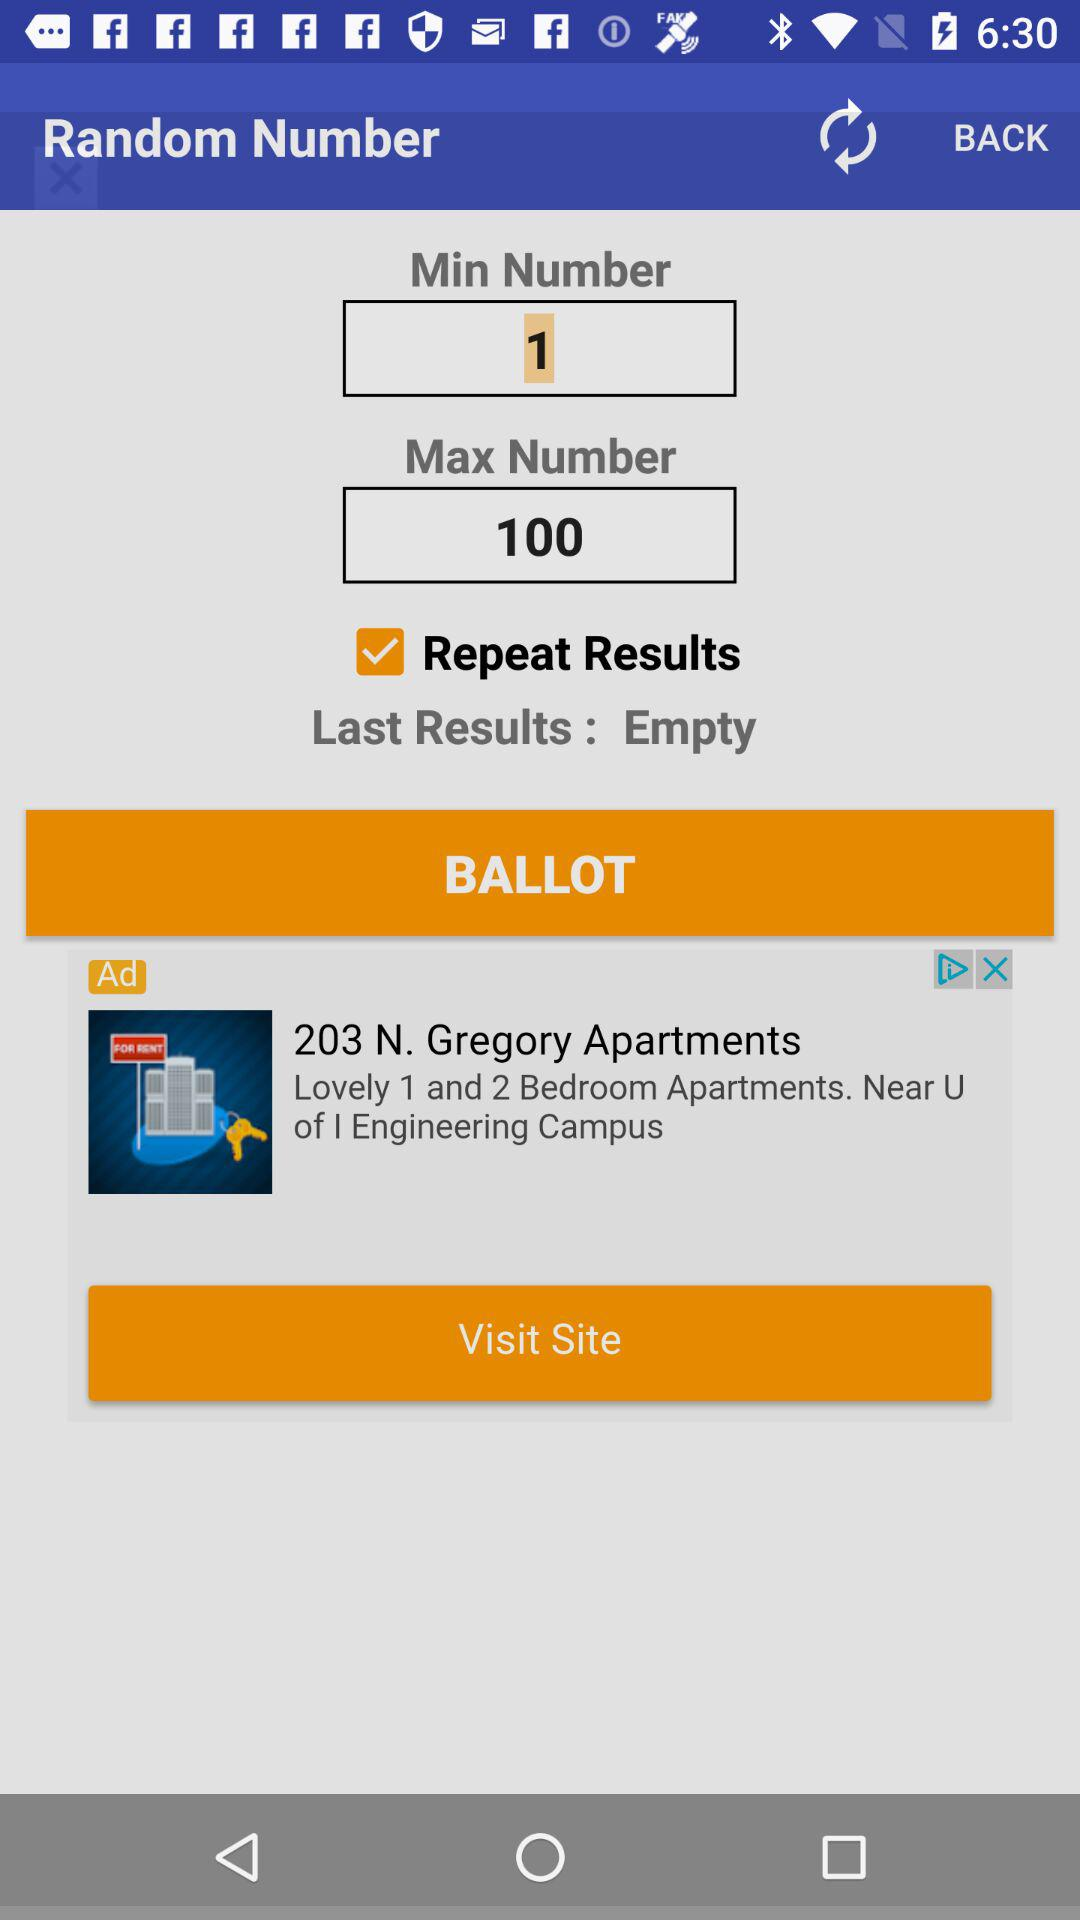What is the difference between the minimum and maximum values?
Answer the question using a single word or phrase. 99 